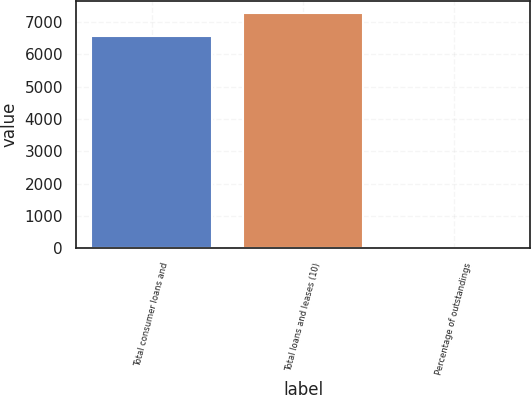<chart> <loc_0><loc_0><loc_500><loc_500><bar_chart><fcel>Total consumer loans and<fcel>Total loans and leases (10)<fcel>Percentage of outstandings<nl><fcel>6564<fcel>7277.42<fcel>0.76<nl></chart> 